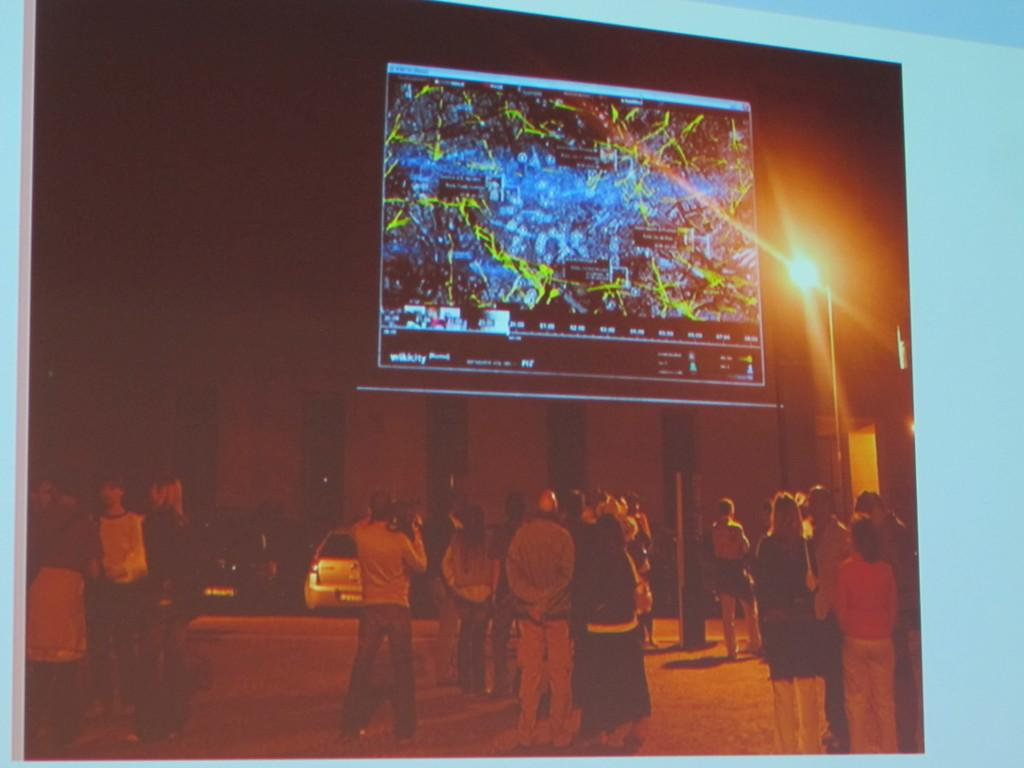What can be seen in the image involving people? There are people standing in the image. What else is present in the image besides people? There are vehicles and a big screen in the image. What type of fuel is being used by the neck in the image? There is no neck or fuel present in the image. Can you tell me how many skateboards are visible in the image? There is no skateboard present in the image. 